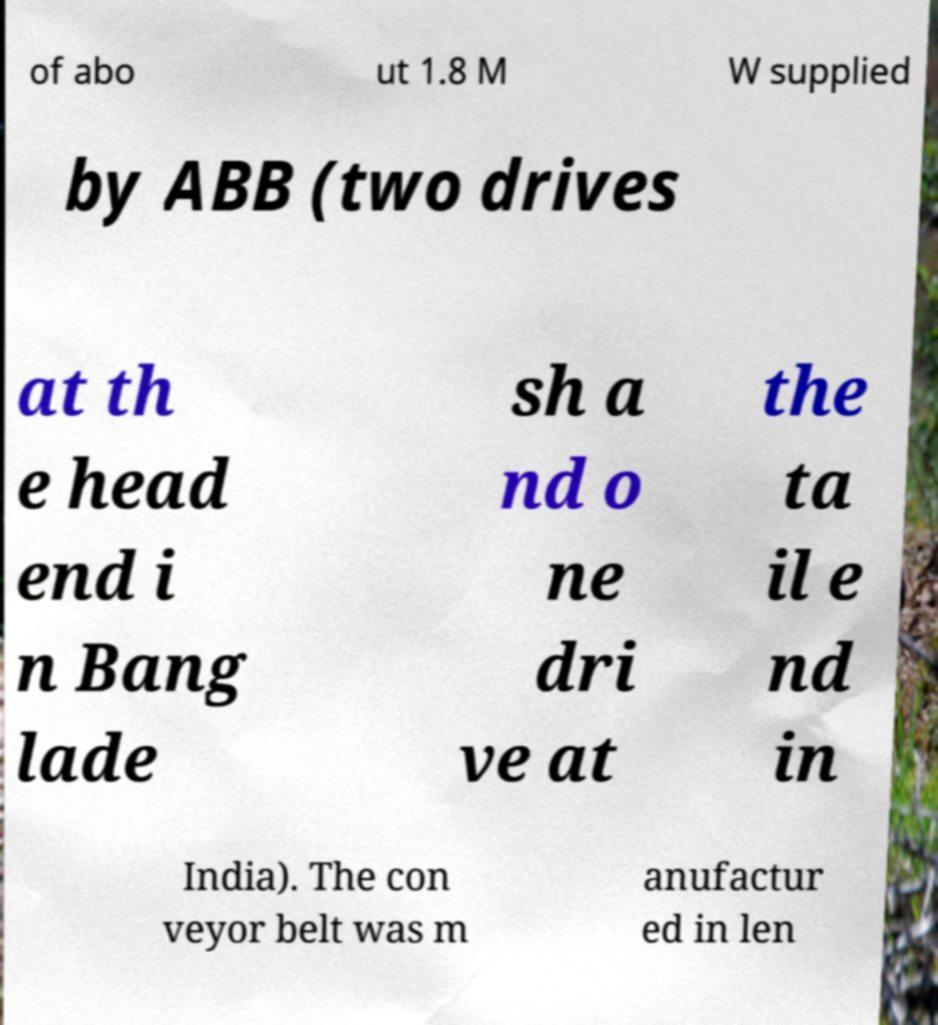Could you assist in decoding the text presented in this image and type it out clearly? of abo ut 1.8 M W supplied by ABB (two drives at th e head end i n Bang lade sh a nd o ne dri ve at the ta il e nd in India). The con veyor belt was m anufactur ed in len 